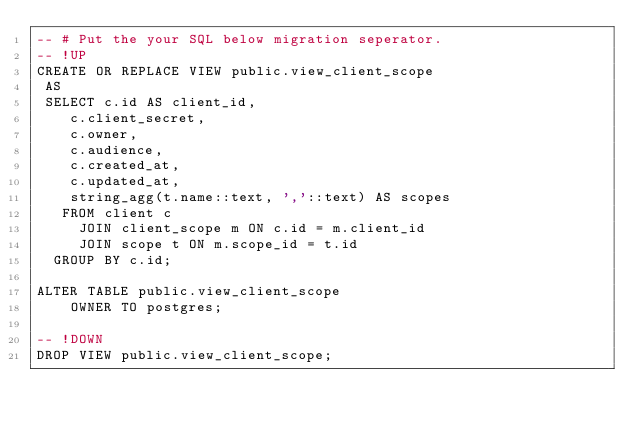Convert code to text. <code><loc_0><loc_0><loc_500><loc_500><_SQL_>-- # Put the your SQL below migration seperator.
-- !UP
CREATE OR REPLACE VIEW public.view_client_scope
 AS
 SELECT c.id AS client_id,
    c.client_secret,
    c.owner,
    c.audience,
    c.created_at,
    c.updated_at,
    string_agg(t.name::text, ','::text) AS scopes
   FROM client c
     JOIN client_scope m ON c.id = m.client_id
     JOIN scope t ON m.scope_id = t.id
  GROUP BY c.id;

ALTER TABLE public.view_client_scope
    OWNER TO postgres;

-- !DOWN
DROP VIEW public.view_client_scope;
</code> 